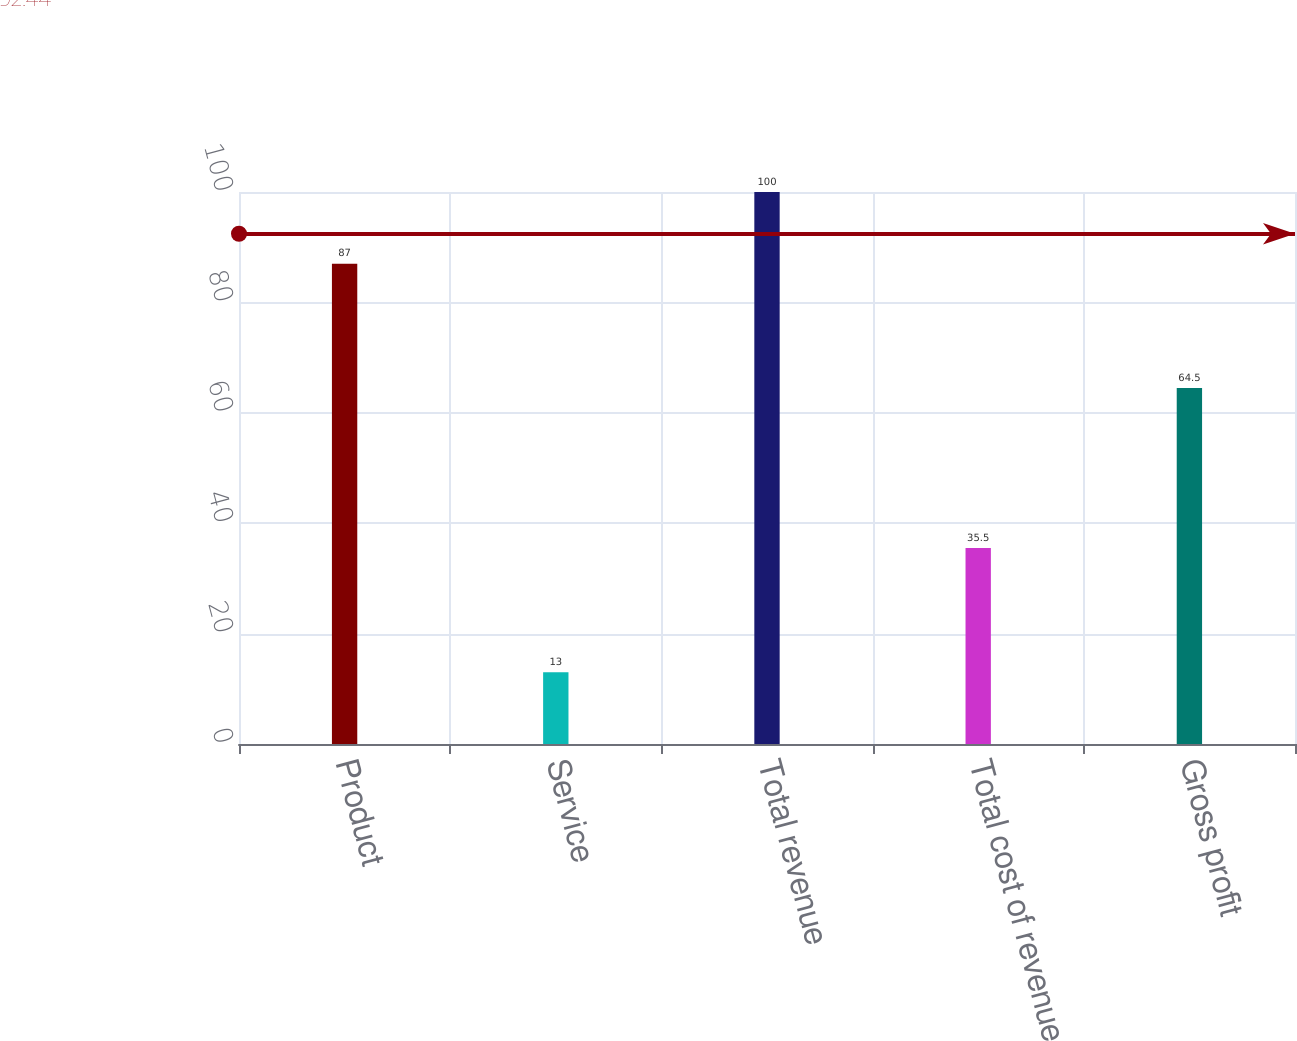<chart> <loc_0><loc_0><loc_500><loc_500><bar_chart><fcel>Product<fcel>Service<fcel>Total revenue<fcel>Total cost of revenue<fcel>Gross profit<nl><fcel>87<fcel>13<fcel>100<fcel>35.5<fcel>64.5<nl></chart> 